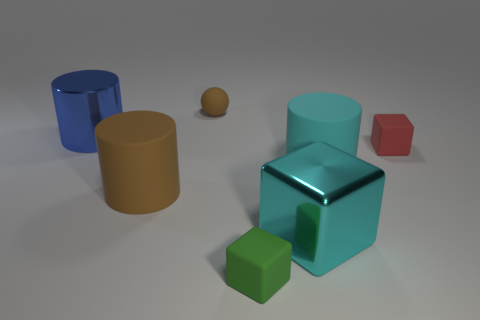Add 3 rubber cylinders. How many objects exist? 10 Subtract all shiny blocks. How many blocks are left? 2 Subtract all cubes. How many objects are left? 4 Add 3 small yellow shiny things. How many small yellow shiny things exist? 3 Subtract 0 yellow cubes. How many objects are left? 7 Subtract 1 balls. How many balls are left? 0 Subtract all blue cylinders. Subtract all gray spheres. How many cylinders are left? 2 Subtract all cyan balls. How many red cylinders are left? 0 Subtract all small red rubber things. Subtract all tiny rubber blocks. How many objects are left? 4 Add 2 small green objects. How many small green objects are left? 3 